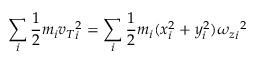<formula> <loc_0><loc_0><loc_500><loc_500>\sum _ { i } { \frac { 1 } { 2 } } m _ { i } { v _ { T } } _ { i } ^ { 2 } = \sum _ { i } { \frac { 1 } { 2 } } m _ { i } ( x _ { i } ^ { 2 } + y _ { i } ^ { 2 } ) { { \omega _ { z } } _ { i } } ^ { 2 }</formula> 